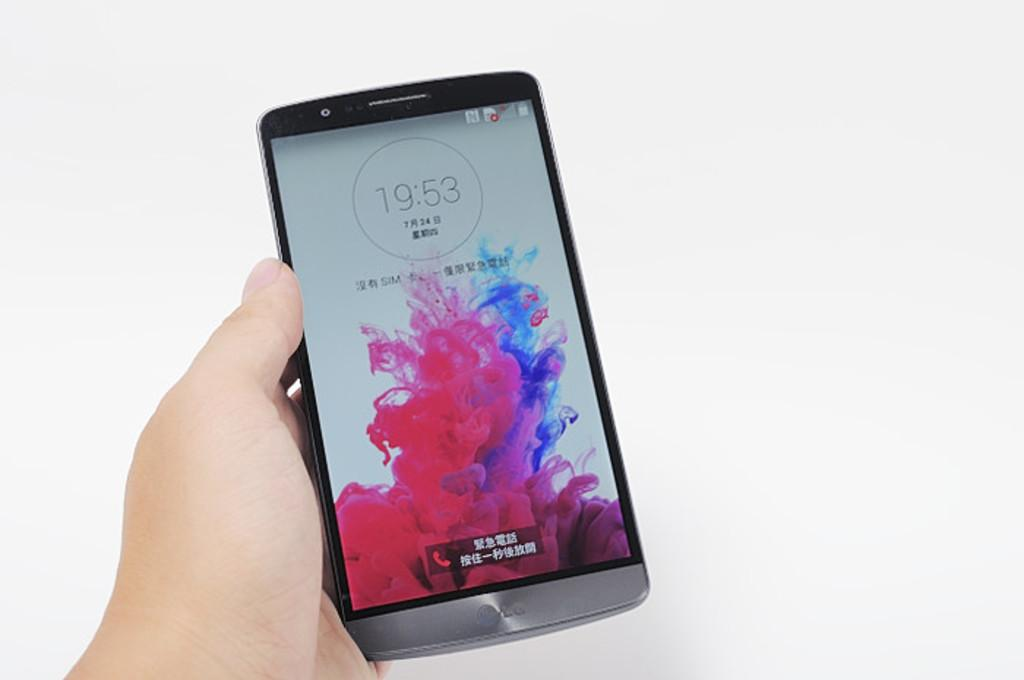<image>
Create a compact narrative representing the image presented. Person's hand holding a large screen cell phone with Japanese letters. 